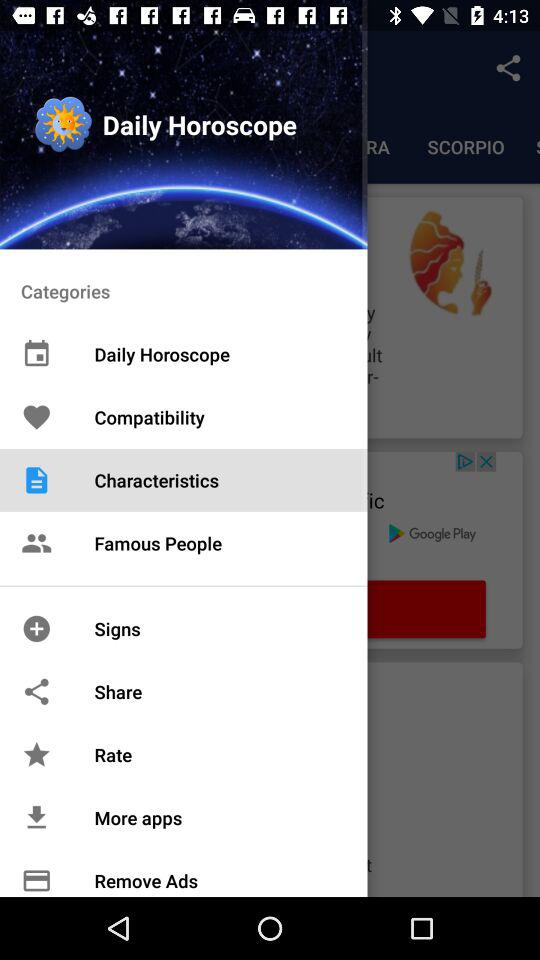What is the date?
When the provided information is insufficient, respond with <no answer>. <no answer> 